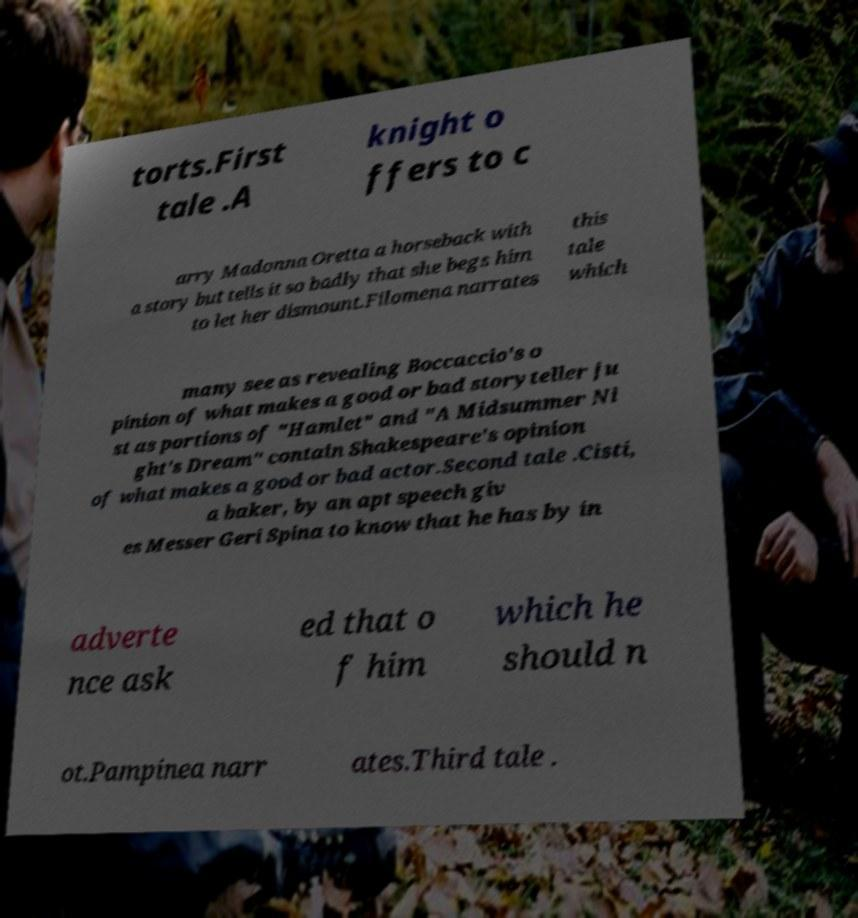Could you extract and type out the text from this image? torts.First tale .A knight o ffers to c arry Madonna Oretta a horseback with a story but tells it so badly that she begs him to let her dismount.Filomena narrates this tale which many see as revealing Boccaccio's o pinion of what makes a good or bad storyteller ju st as portions of "Hamlet" and "A Midsummer Ni ght's Dream" contain Shakespeare's opinion of what makes a good or bad actor.Second tale .Cisti, a baker, by an apt speech giv es Messer Geri Spina to know that he has by in adverte nce ask ed that o f him which he should n ot.Pampinea narr ates.Third tale . 